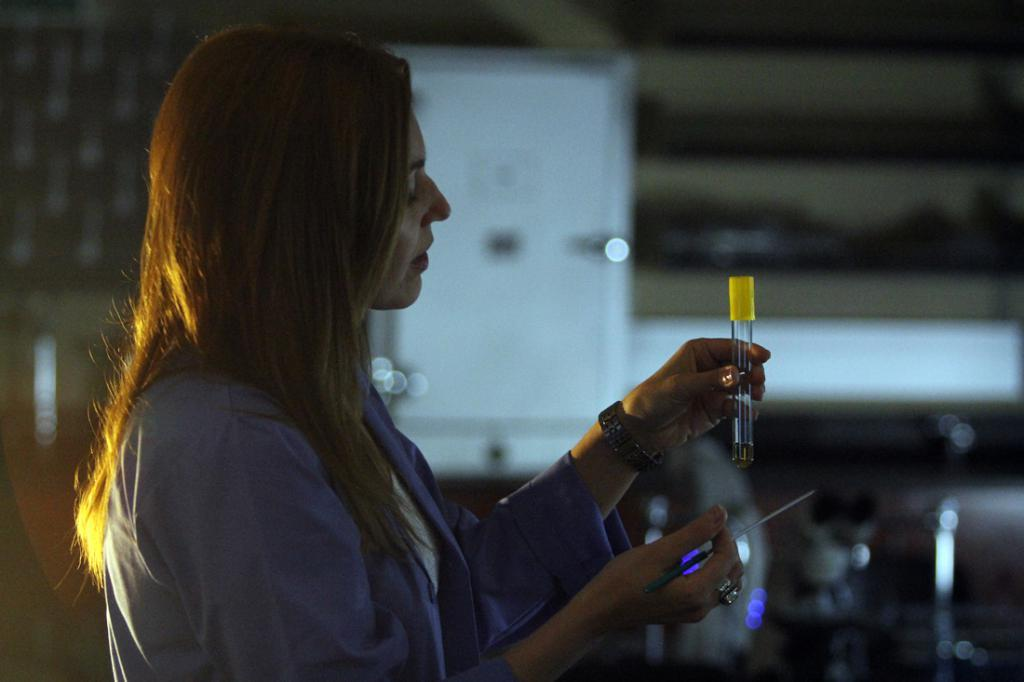Who is the main subject in the image? There is a woman in the image. Where is the woman located in the image? The woman is standing on a path. What is the woman holding in the image? The woman is holding some objects. Can you describe the background of the image? There are blurred items in the background of the image. What type of thumb is visible in the image? There is no thumb present in the image. Can you describe the mist in the image? There is no mist present in the image. 